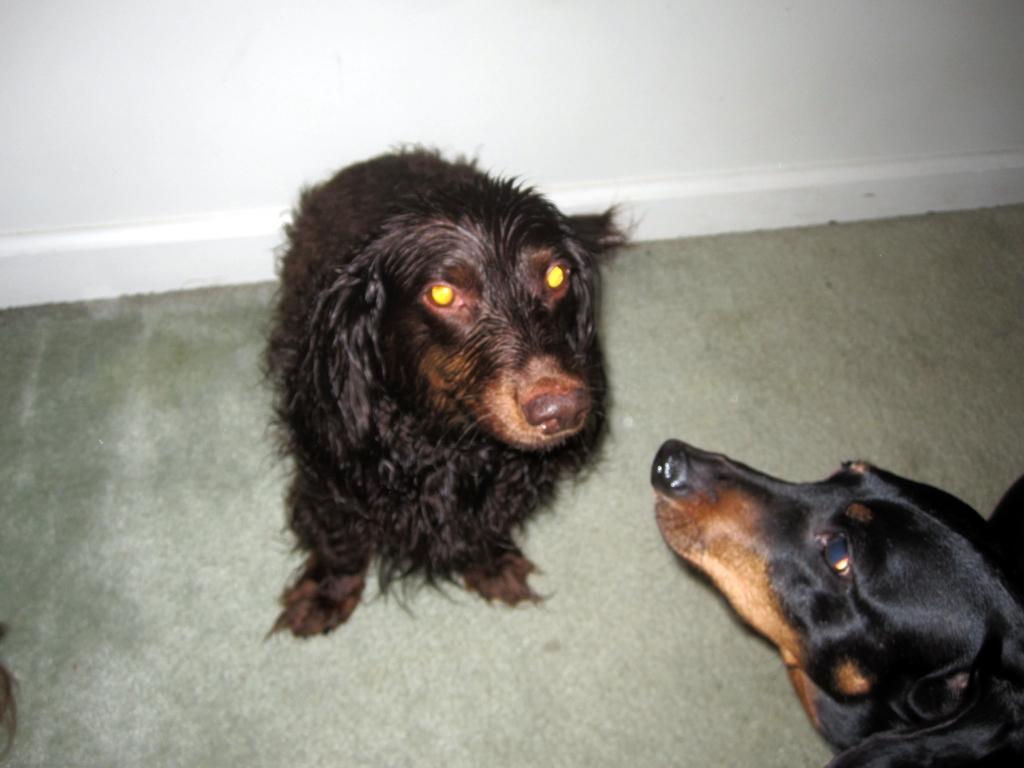In one or two sentences, can you explain what this image depicts? This picture is taken inside the room. In this image, in the right side corner, we can see the head of a dog. In the middle of the image, we can see a dog. In the background, we can see a wall which is in white color. On the left side, we can see a hair. 